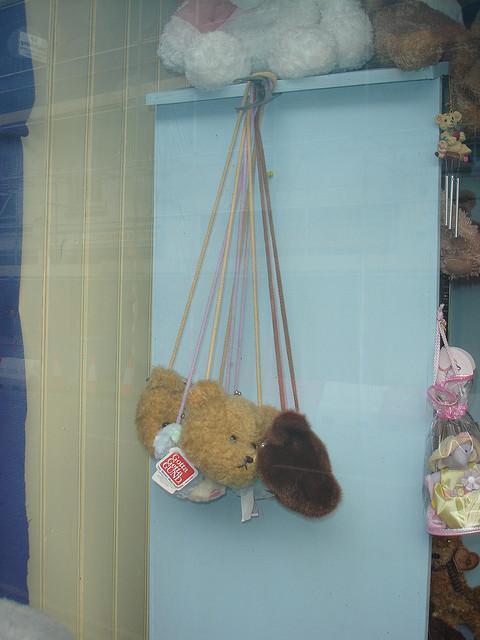What is the bear here doing?
Select the accurate answer and provide justification: `Answer: choice
Rationale: srationale.`
Options: Running, hanging, eating, jumping. Answer: hanging.
Rationale: It is attached to strings 